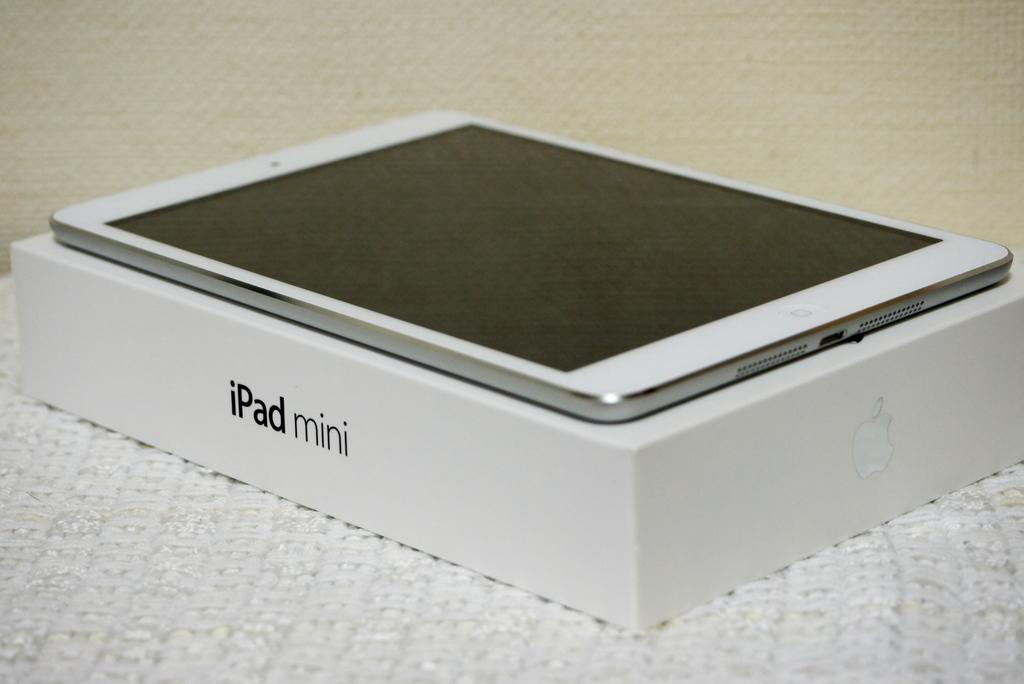<image>
Create a compact narrative representing the image presented. An iPad mini sitting on a box saying ipad Mini. 